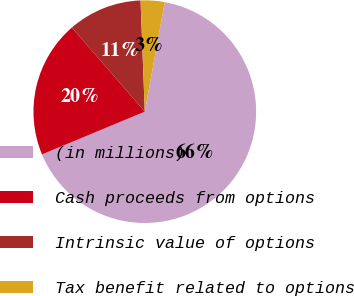Convert chart to OTSL. <chart><loc_0><loc_0><loc_500><loc_500><pie_chart><fcel>(in millions)<fcel>Cash proceeds from options<fcel>Intrinsic value of options<fcel>Tax benefit related to options<nl><fcel>65.87%<fcel>19.91%<fcel>10.76%<fcel>3.47%<nl></chart> 